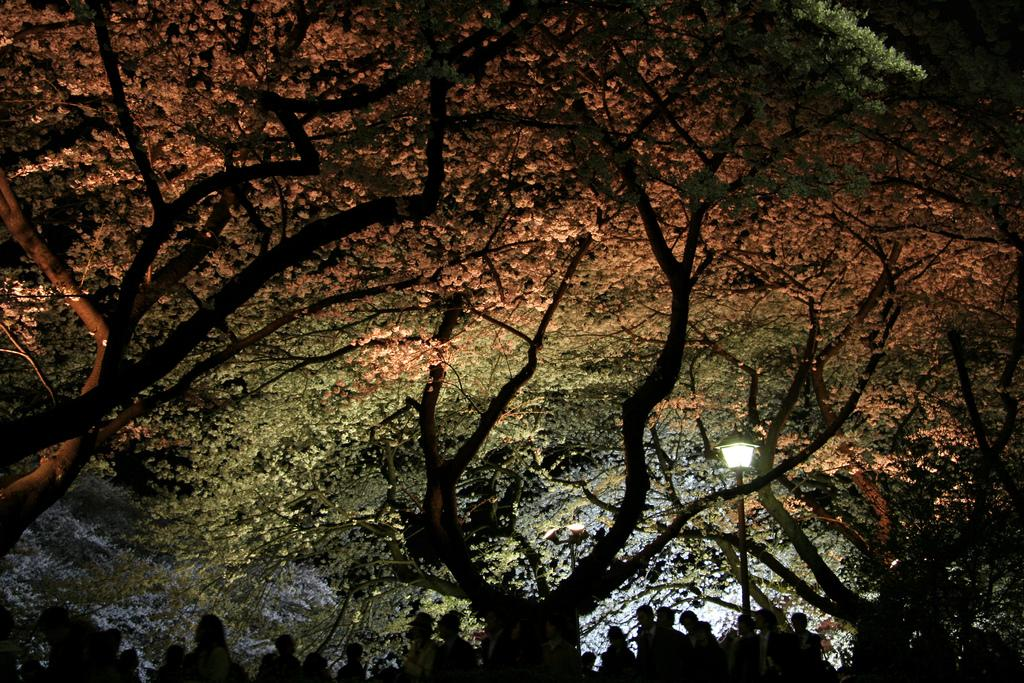What type of natural elements can be seen in the image? There are trees in the image. What else can be seen at the bottom of the image? There are people at the bottom of the image. What structure is present in the image? There is a pole in the image. What is attached to the pole? There is a light on the pole. Can you see any volcanoes erupting in the image? There are no volcanoes present in the image. What type of fish can be seen swimming near the people in the image? There are no fish present in the image. 